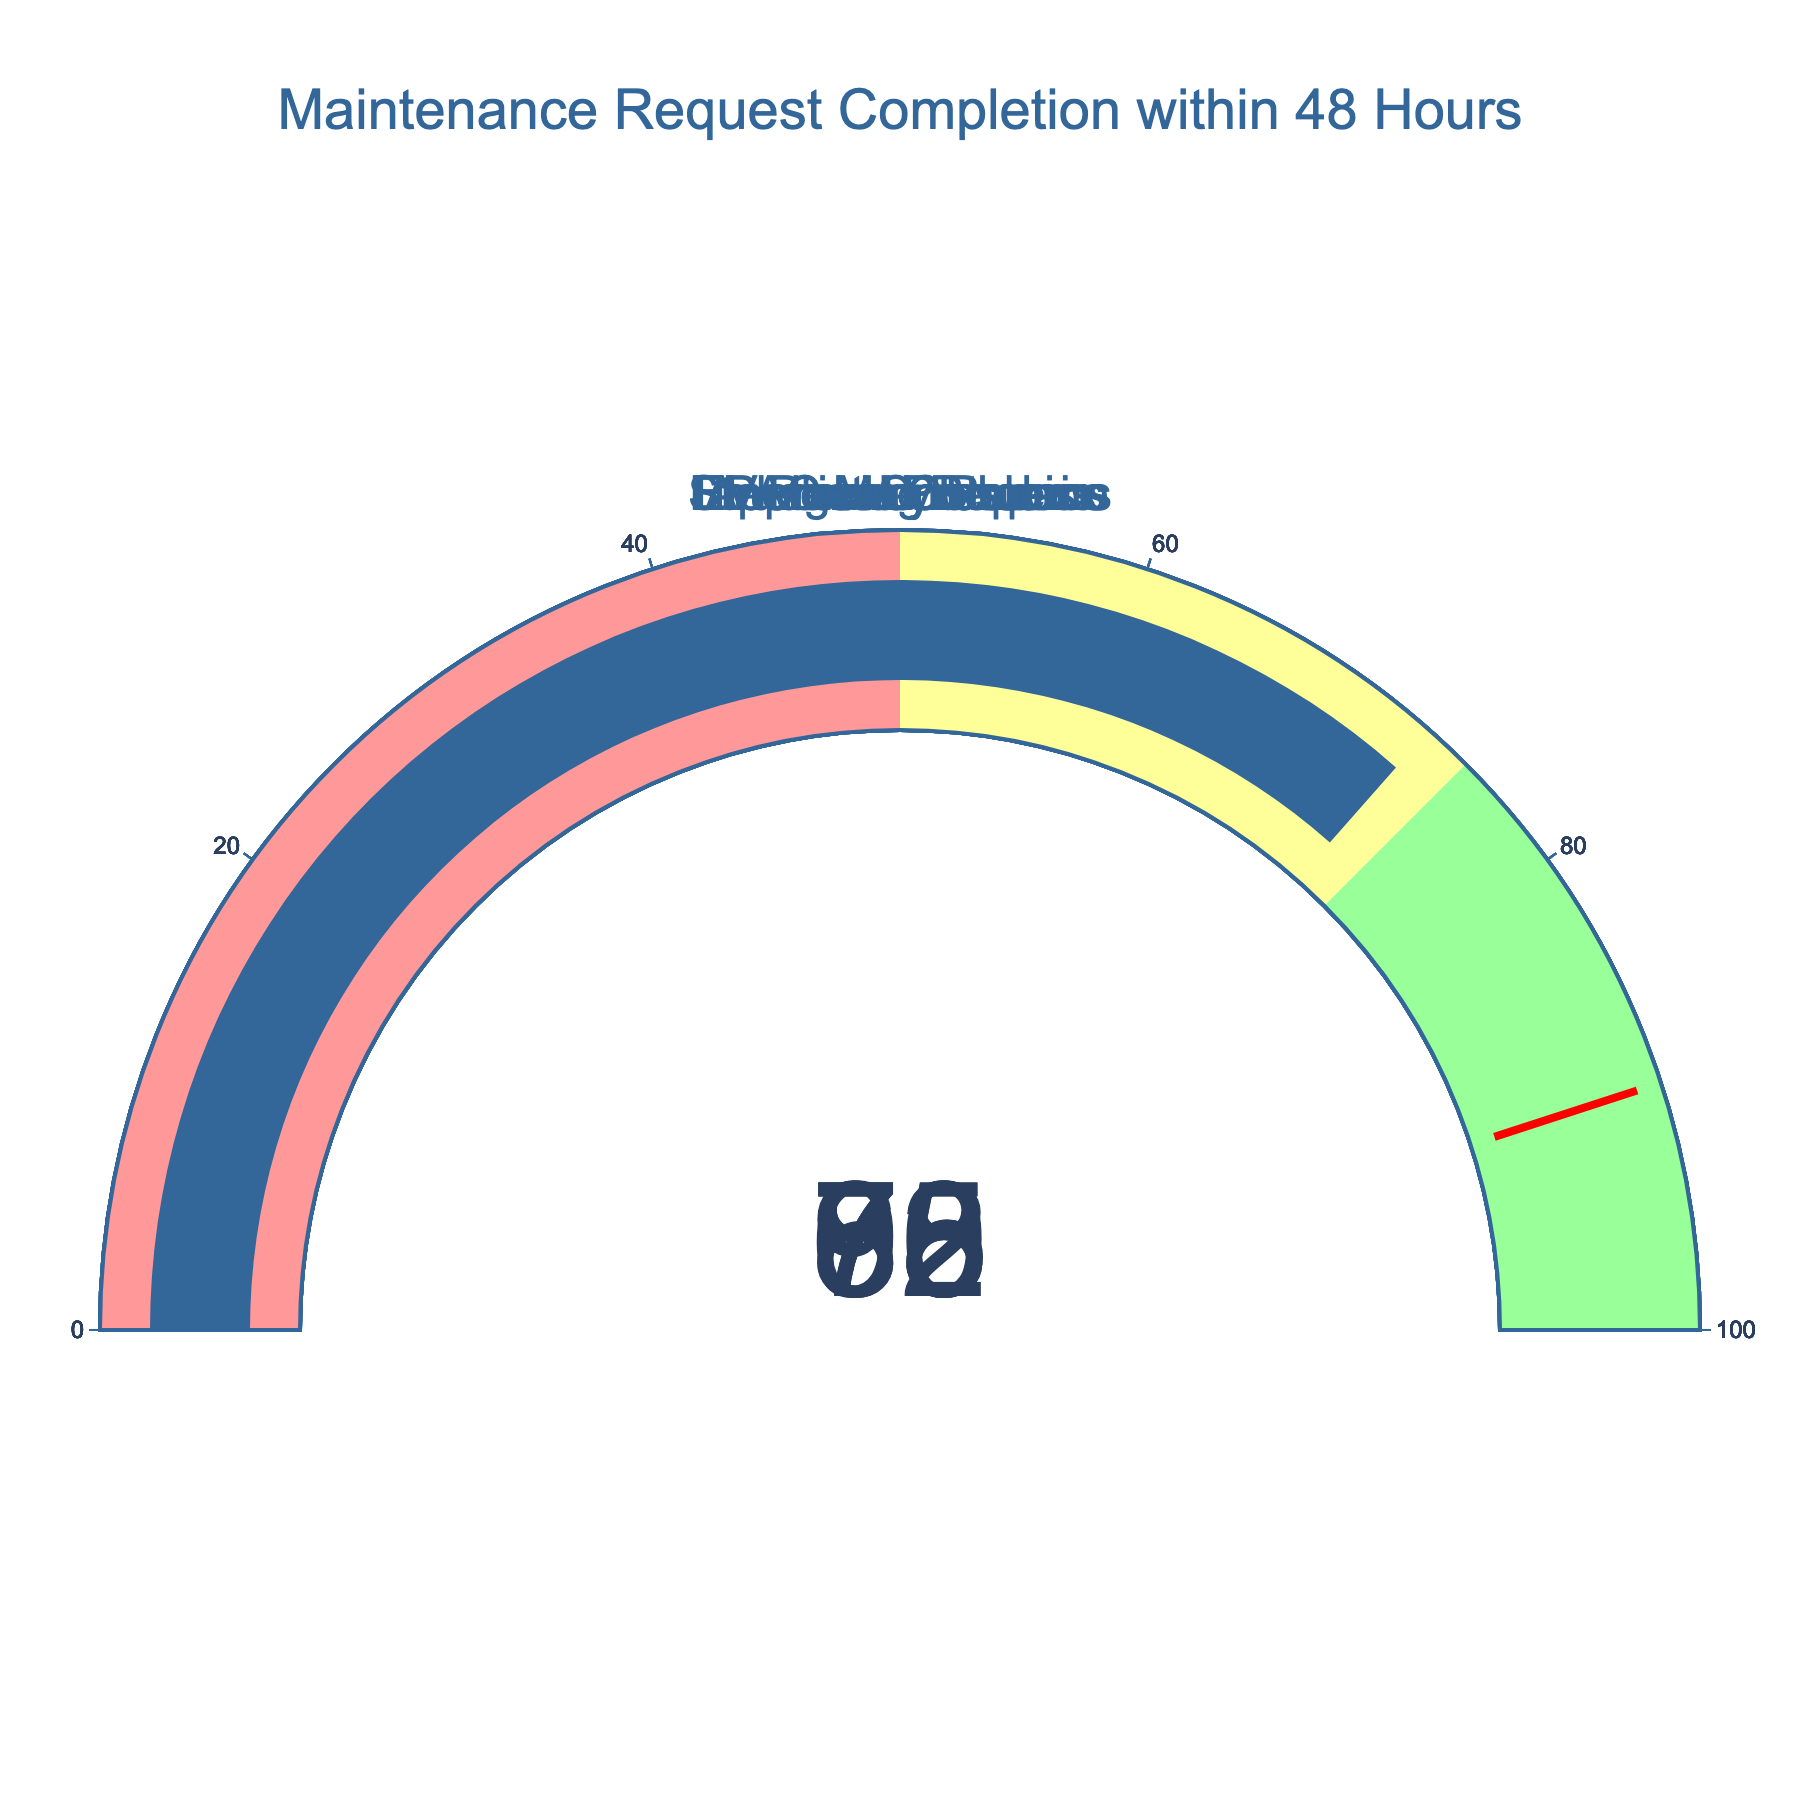How many categories are displayed in the figure? There is a separate gauge for each category listed in the data. Count the number of unique categories from the figure.
Answer: 7 Which maintenance request category has the highest completion percentage within 48 hours? Look for the gauge with the highest value displayed among all categories.
Answer: Emergency Repairs Which maintenance request category has a completion percentage within 48 hours of 85%? Identify the gauge that shows a value of 85% and read the category title.
Answer: Electrical Problems What is the difference in completion percentage between HVAC Maintenance and Plumbing Issues? Subtract the percentage value of HVAC Maintenance from that of Plumbing Issues (78% - 70%).
Answer: 8 Which maintenance request categories have a completion percentage within 48 hours of more than 75%? Identify all gauges with values above 75% and list their categories.
Answer: Emergency Repairs, Electrical Problems, Structural Concerns, Plumbing Issues Is the completion percentage for Appliance Repairs above or below the threshold value of 90%? Compare the value displayed for Appliance Repairs (65%) with the threshold value (90%).
Answer: Below Which category needs the most improvement based on the completion percentage within 48 hours? Identify the gauge with the lowest percentage value.
Answer: Appliance Repairs Are there more maintenance request categories with completion percentages above or below 80%? Count the gauges with values above 80% and those below 80%, then compare the counts.
Answer: Below What is the median completion percentage across all categories? Arrange the percentages in ascending order and identify the middle value. The percentages are 65, 70, 73, 78, 85, 88, 92, so the median is the fourth value, which is 78.
Answer: 78 